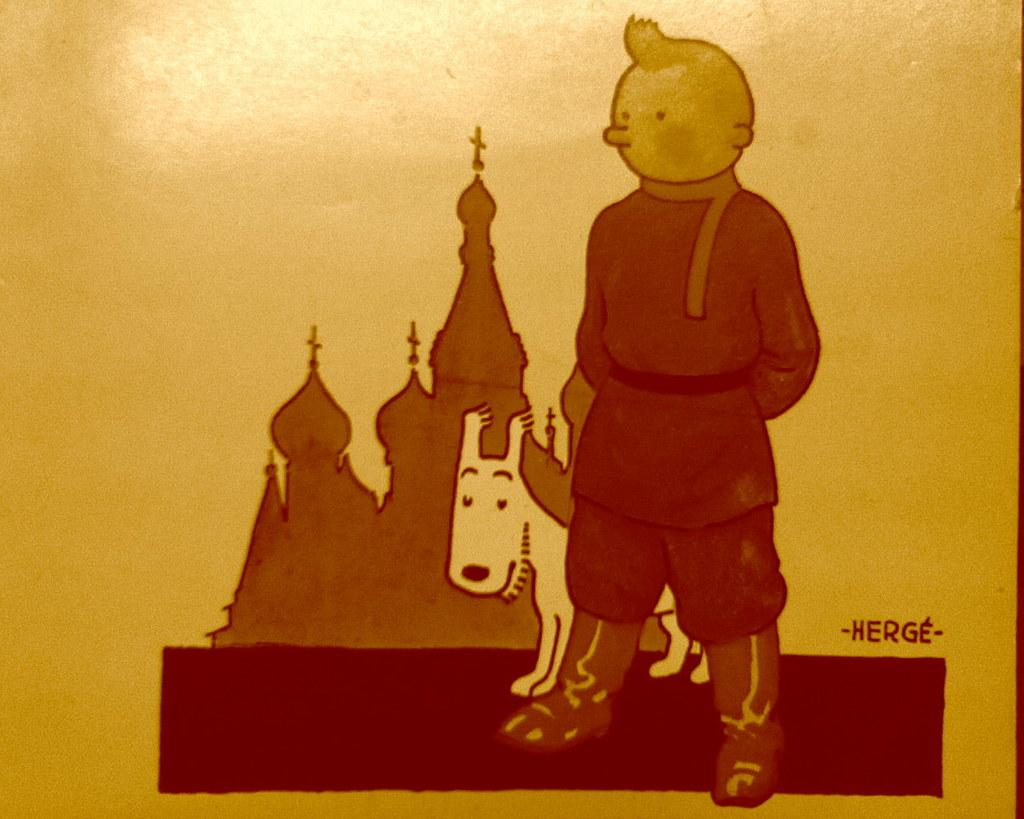What types of subjects are depicted in the art of the image? There is an art of a person and an art of an animal in the image. What else can be seen in the image besides the art? There is text in the image. What color is the background of the image? The background of the image is yellow. What type of chain is being used to hold up the trousers in the image? There is no chain or trousers present in the image. 